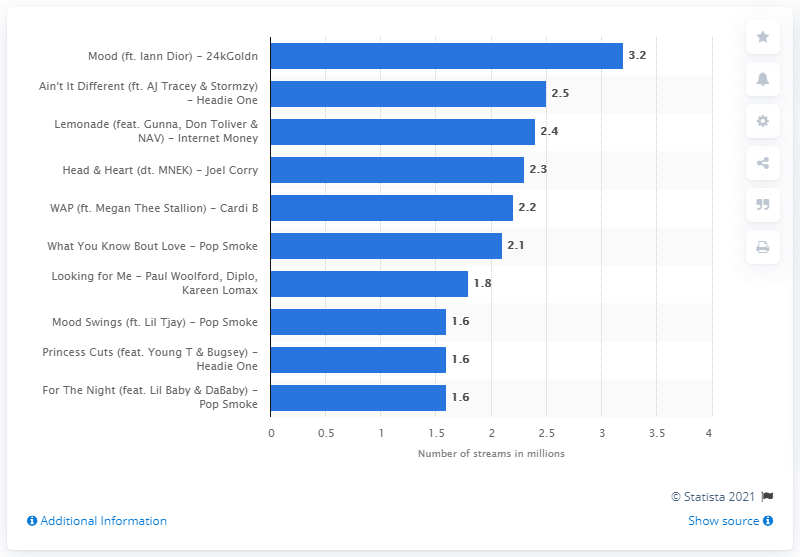Indicate a few pertinent items in this graphic. As of the UK, 24kGoldn's Mood on Spotify received 3.2 streams. According to data from Spotify in the UK, 24kGoldn's Mood received 3.2 streams. 